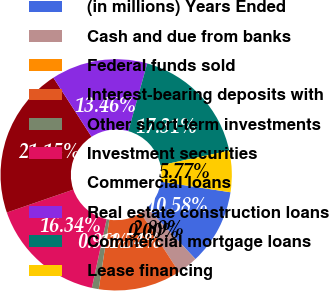Convert chart to OTSL. <chart><loc_0><loc_0><loc_500><loc_500><pie_chart><fcel>(in millions) Years Ended<fcel>Cash and due from banks<fcel>Federal funds sold<fcel>Interest-bearing deposits with<fcel>Other short-term investments<fcel>Investment securities<fcel>Commercial loans<fcel>Real estate construction loans<fcel>Commercial mortgage loans<fcel>Lease financing<nl><fcel>10.58%<fcel>2.89%<fcel>0.0%<fcel>11.54%<fcel>0.96%<fcel>16.34%<fcel>21.15%<fcel>13.46%<fcel>17.31%<fcel>5.77%<nl></chart> 